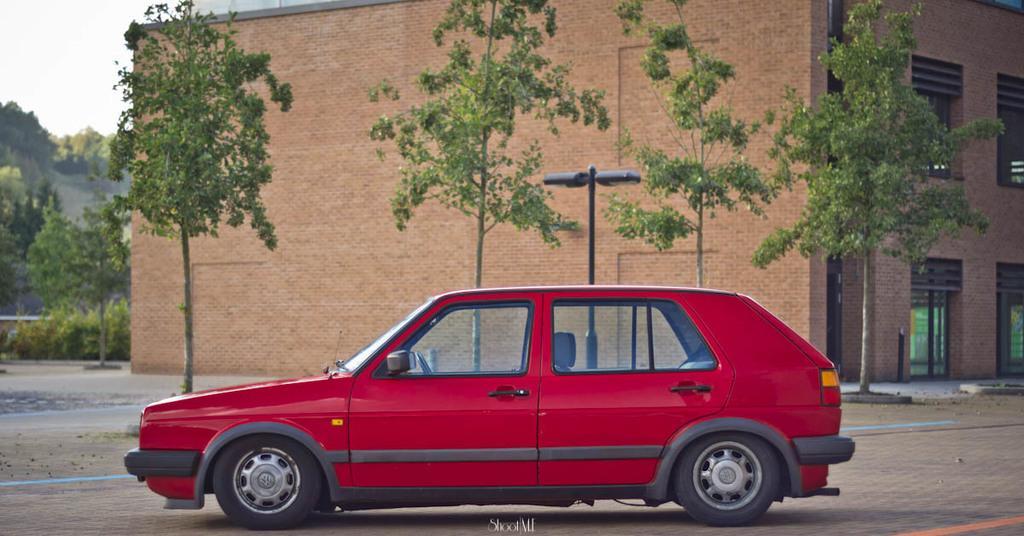Can you describe this image briefly? In this picture we can see a car on the road, trees, plants, lights on pole and building. In the background of the image we can see the sky. 